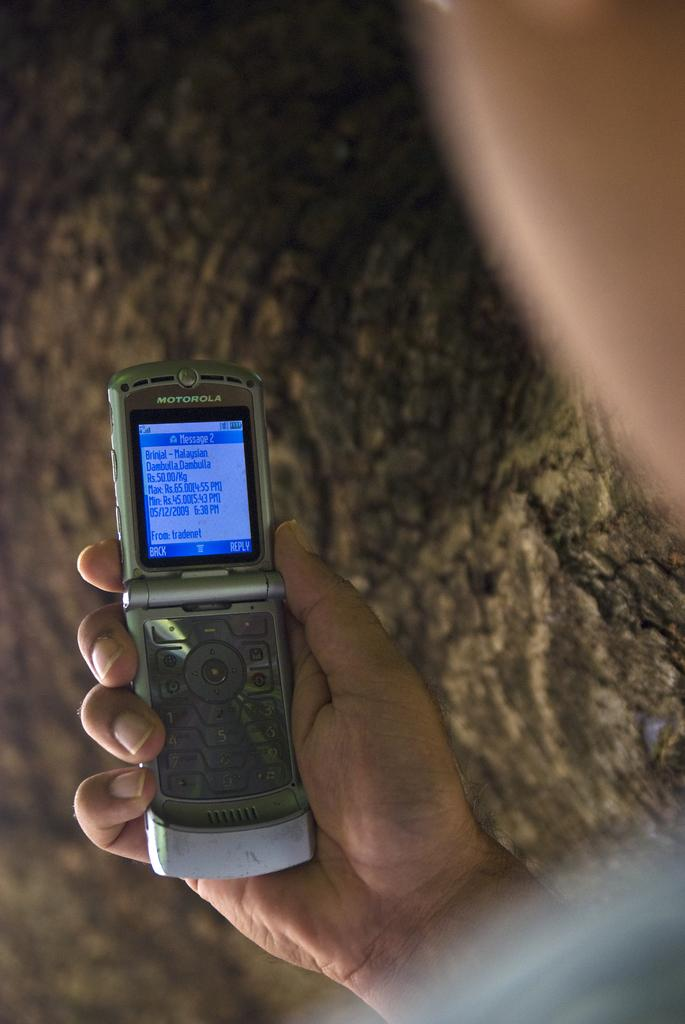<image>
Share a concise interpretation of the image provided. A cellphone in a hand shows a message from Tradenet. 